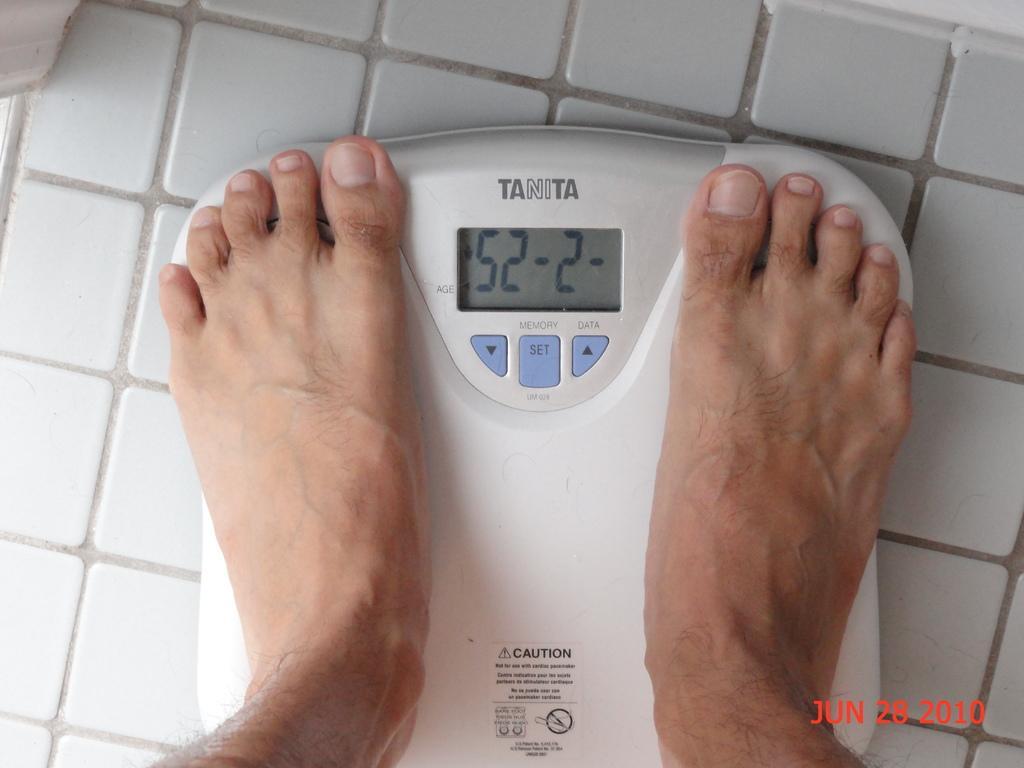How would you summarize this image in a sentence or two? In the picture we can see a tiled floor on it we can see a weight machine with a person legs on it. 